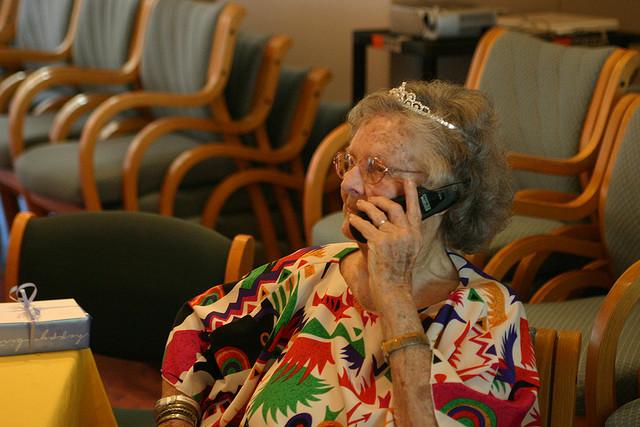What is sitting on the table in front of the lady?
Quick response, please. Gift. How old is the lady?
Give a very brief answer. 78. What is the lady wearing in her head?
Quick response, please. Tiara. 